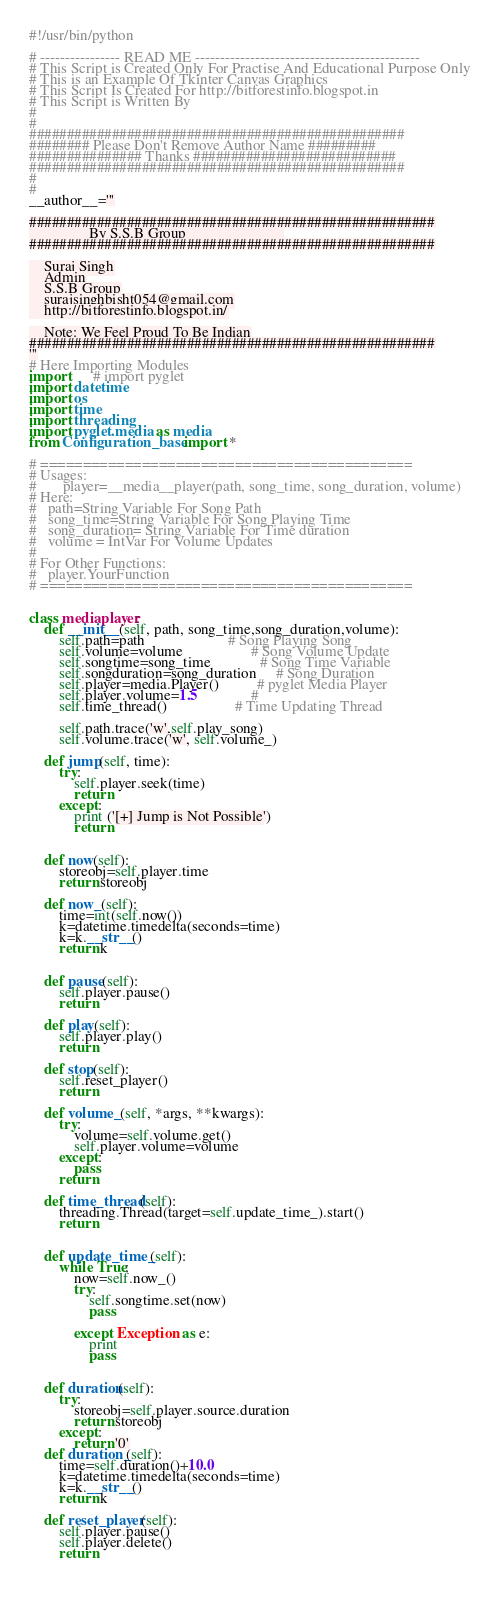Convert code to text. <code><loc_0><loc_0><loc_500><loc_500><_Python_>#!/usr/bin/python

# ---------------- READ ME ---------------------------------------------
# This Script is Created Only For Practise And Educational Purpose Only
# This is an Example Of Tkinter Canvas Graphics
# This Script Is Created For http://bitforestinfo.blogspot.in
# This Script is Written By
#
#
##################################################
######## Please Don't Remove Author Name #########
############### Thanks ###########################
##################################################
#
#
__author__='''

######################################################
                By S.S.B Group                          
######################################################

    Suraj Singh
    Admin
    S.S.B Group
    surajsinghbisht054@gmail.com
    http://bitforestinfo.blogspot.in/

    Note: We Feel Proud To Be Indian
######################################################
'''
# Here Importing Modules
import      # import pyglet
import datetime
import os
import time
import threading
import pyglet.media as media
from Configuration_base import *

# ============================================
# Usages:
#       player=__media__player(path, song_time, song_duration, volume)
# Here:
#   path=String Variable For Song Path
#   song_time=String Variable For Song Playing Time
#   song_duration= String Variable For Time duration
#   volume = IntVar For Volume Updates
#
# For Other Functions:
#   player.YourFunction
# ============================================


class mediaplayer:
    def __init__(self, path, song_time,song_duration,volume):
        self.path=path                      # Song Playing Song
        self.volume=volume                  # Song Volume Update
        self.songtime=song_time             # Song Time Variable
        self.songduration=song_duration     # Song Duration
        self.player=media.Player()          # pyglet Media Player
        self.player.volume=1.5              # 
        self.time_thread()                  # Time Updating Thread

        self.path.trace('w',self.play_song)
        self.volume.trace('w', self.volume_)
        
    def jump(self, time):
        try:
            self.player.seek(time)
            return 
        except:
            print ('[+] Jump is Not Possible')
            return
        
        
    def now(self):
        storeobj=self.player.time
        return storeobj
    
    def now_(self):
        time=int(self.now())
        k=datetime.timedelta(seconds=time)
        k=k.__str__()
        return k

        
    def pause(self):
        self.player.pause()    
        return 

    def play(self):
        self.player.play()
        return
    
    def stop(self):
        self.reset_player()
        return
    
    def volume_(self, *args, **kwargs):
        try:
            volume=self.volume.get()
            self.player.volume=volume
        except:
            pass
        return
    
    def time_thread(self):
        threading.Thread(target=self.update_time_).start()
        return
    
        
    def update_time_(self):
        while True:
            now=self.now_()
            try:
                self.songtime.set(now)
                pass
            
            except Exception as e:
                print 
                pass
        
    
    def duration(self):
        try:
            storeobj=self.player.source.duration
            return storeobj
        except:
            return '0'
    def duration_(self):
        time=self.duration()+10.0
        k=datetime.timedelta(seconds=time)
        k=k.__str__()
        return k
    
    def reset_player(self):
        self.player.pause()
        self.player.delete()
        return
            
            
    </code> 